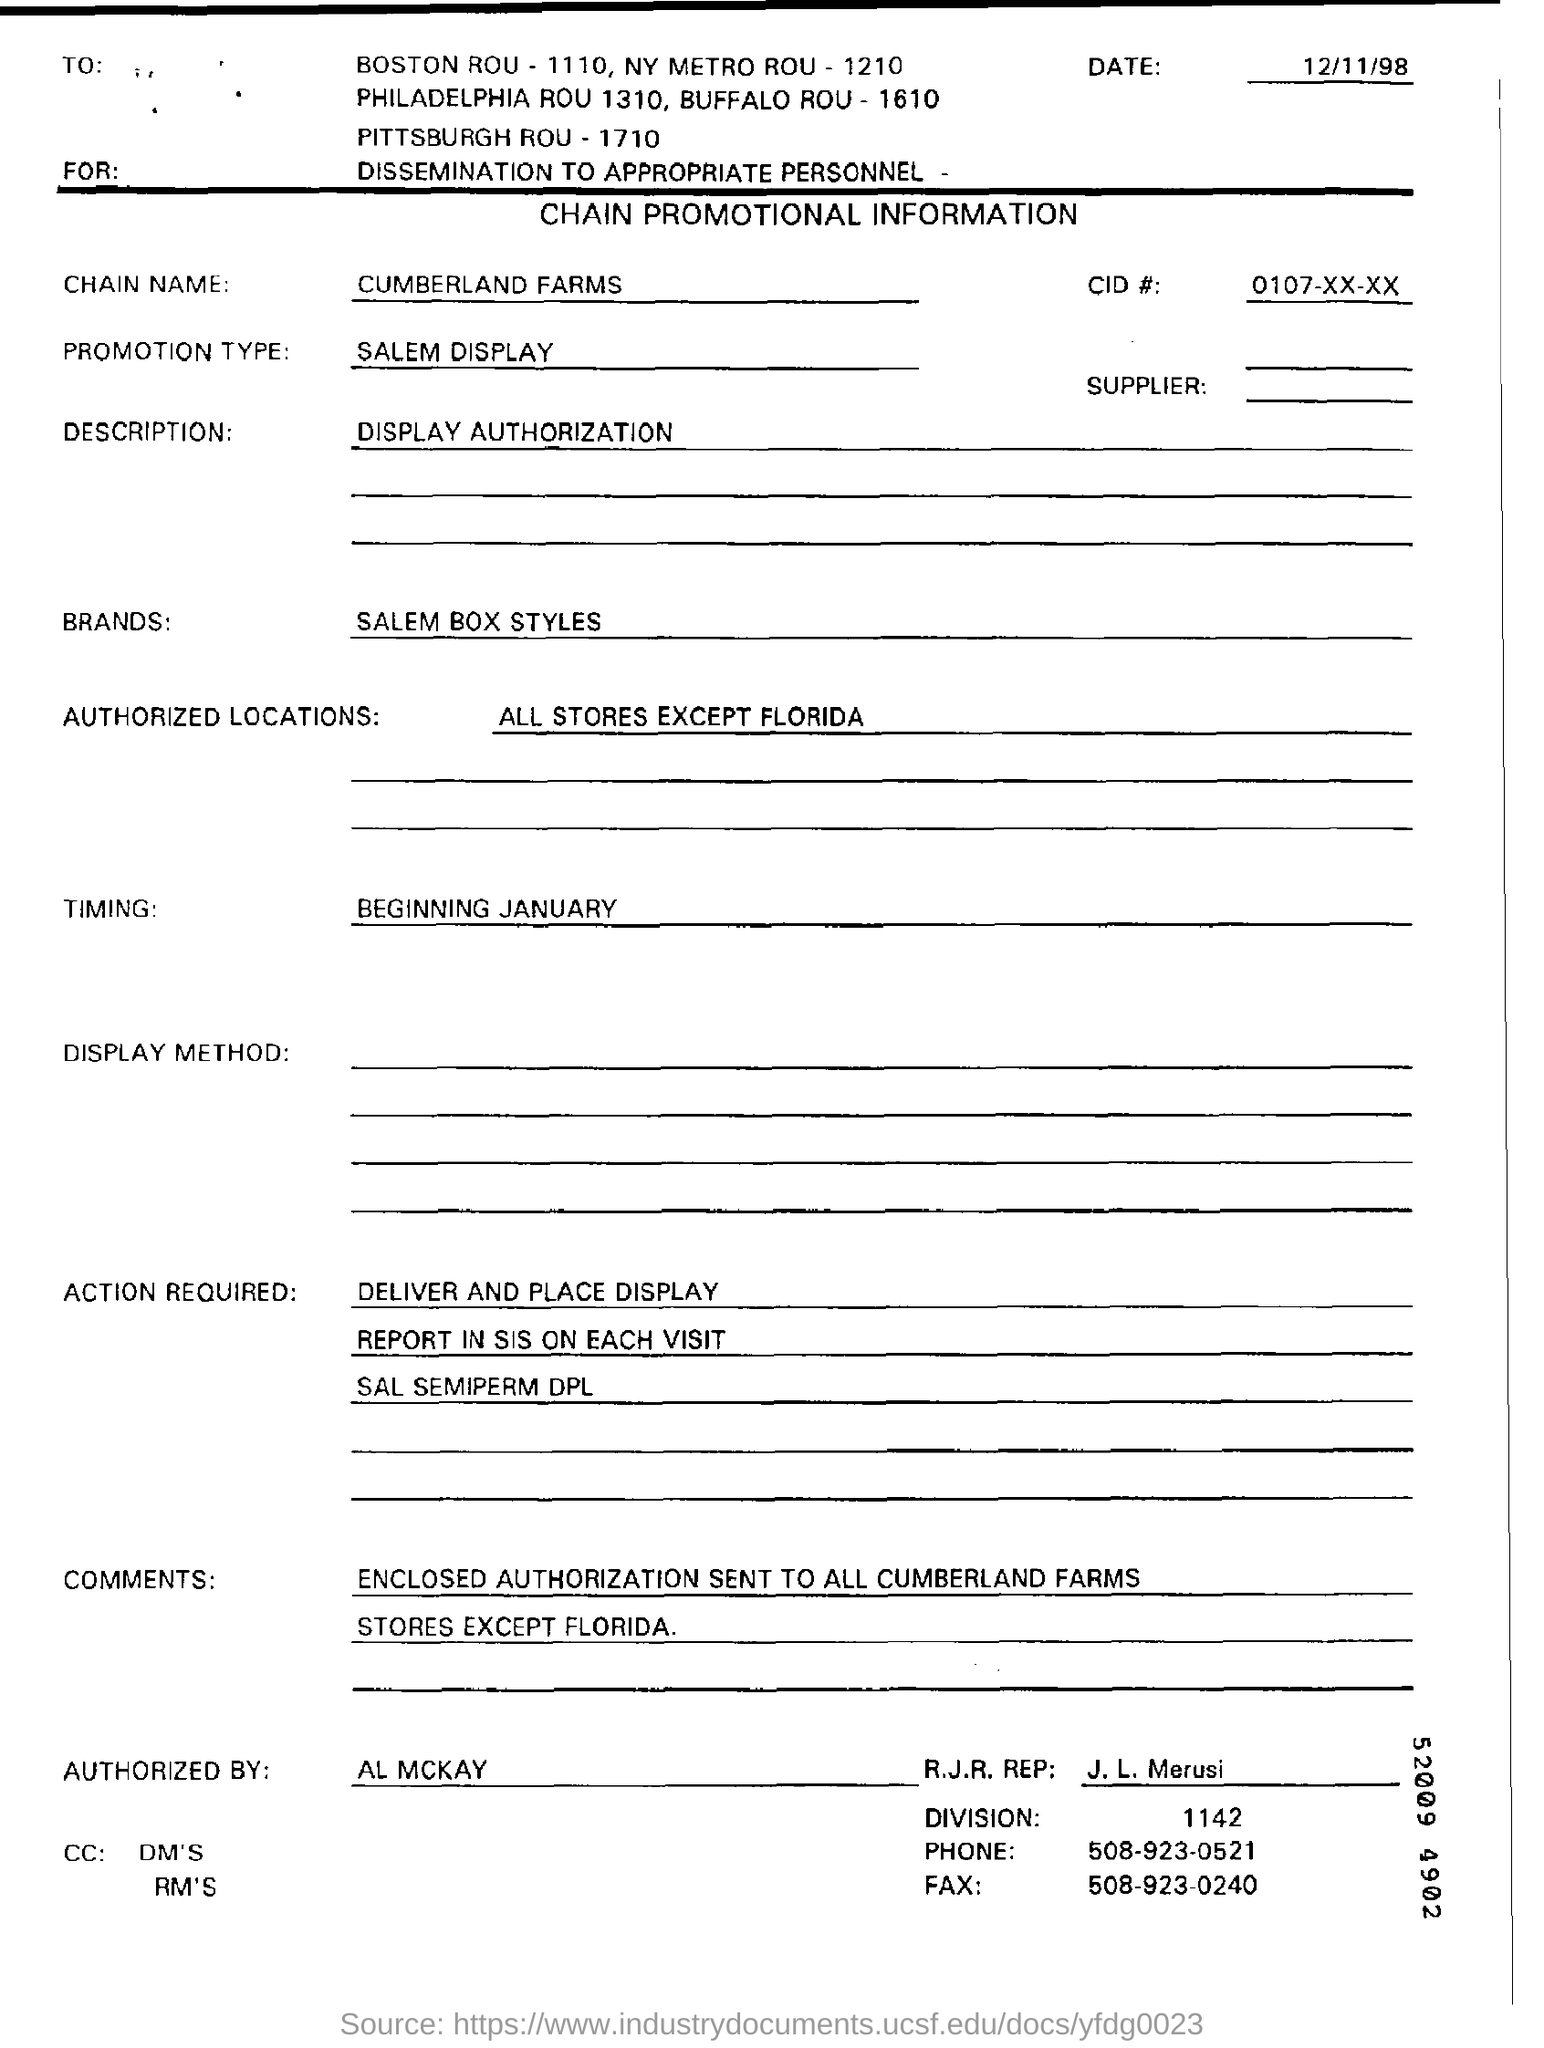Name of the brand ?
Keep it short and to the point. SALEM BOX STYLES. What is timing ?
Give a very brief answer. BEGINNING JANUARY. 